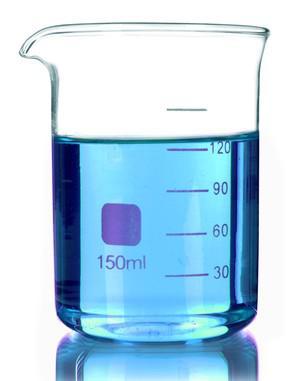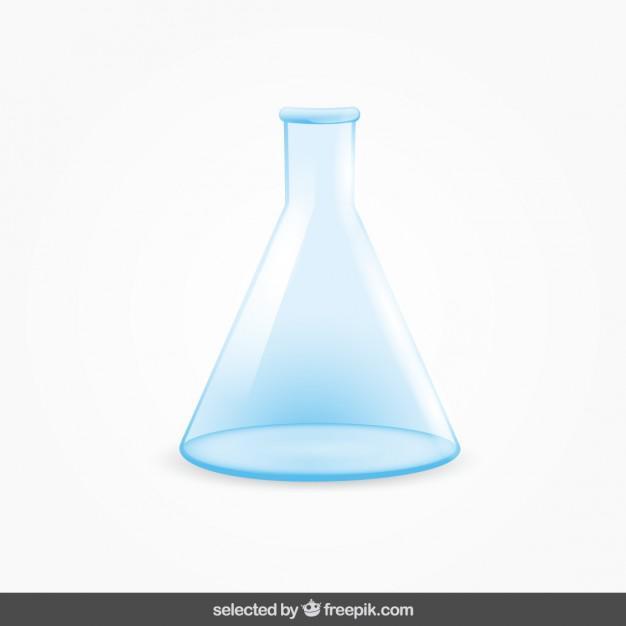The first image is the image on the left, the second image is the image on the right. Evaluate the accuracy of this statement regarding the images: "An image contains just one beaker, which is cylinder shaped.". Is it true? Answer yes or no. Yes. The first image is the image on the left, the second image is the image on the right. Considering the images on both sides, is "One or more beakers in one image are partially filled with colored liquid, while the one beaker in the other image is triangular shaped and empty." valid? Answer yes or no. Yes. 